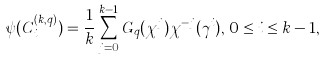<formula> <loc_0><loc_0><loc_500><loc_500>\psi ( C _ { i } ^ { ( k , q ) } ) = \frac { 1 } { k } \sum _ { j = 0 } ^ { k - 1 } G _ { q } ( \chi ^ { j } ) \chi ^ { - j } ( \gamma ^ { i } ) , \, 0 \leq i \leq k - 1 ,</formula> 